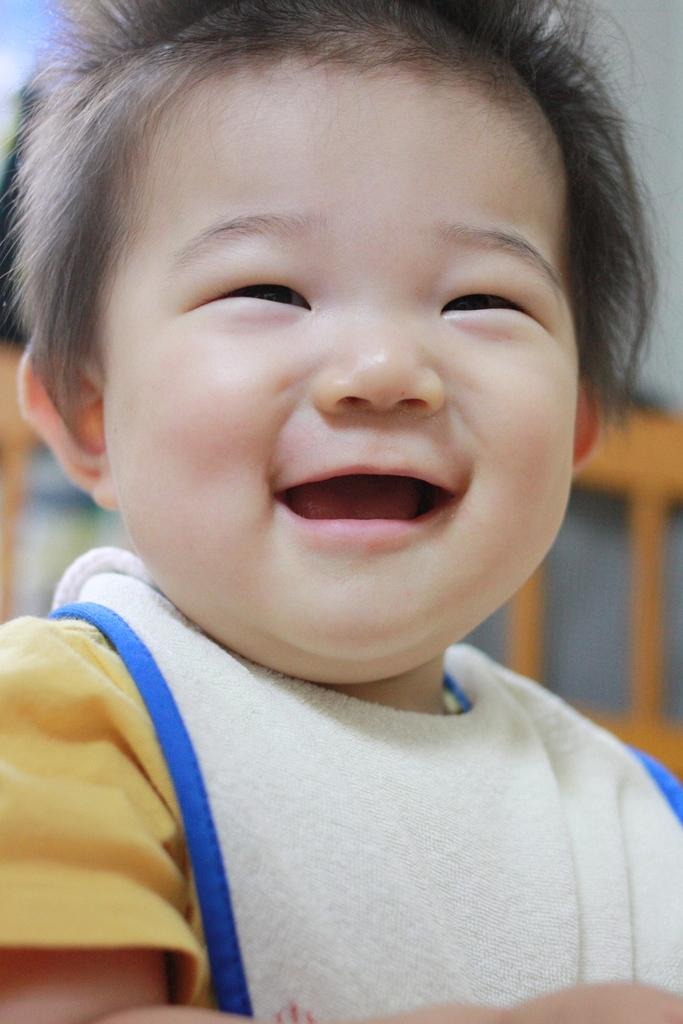What is the main subject of the image? The main subject of the image is a kid. What is the kid's expression in the image? The kid is smiling in the image. What type of notebook is the kid using to trade during the night in the image? There is no notebook or trading activity present in the image; it only features a kid who is smiling. 